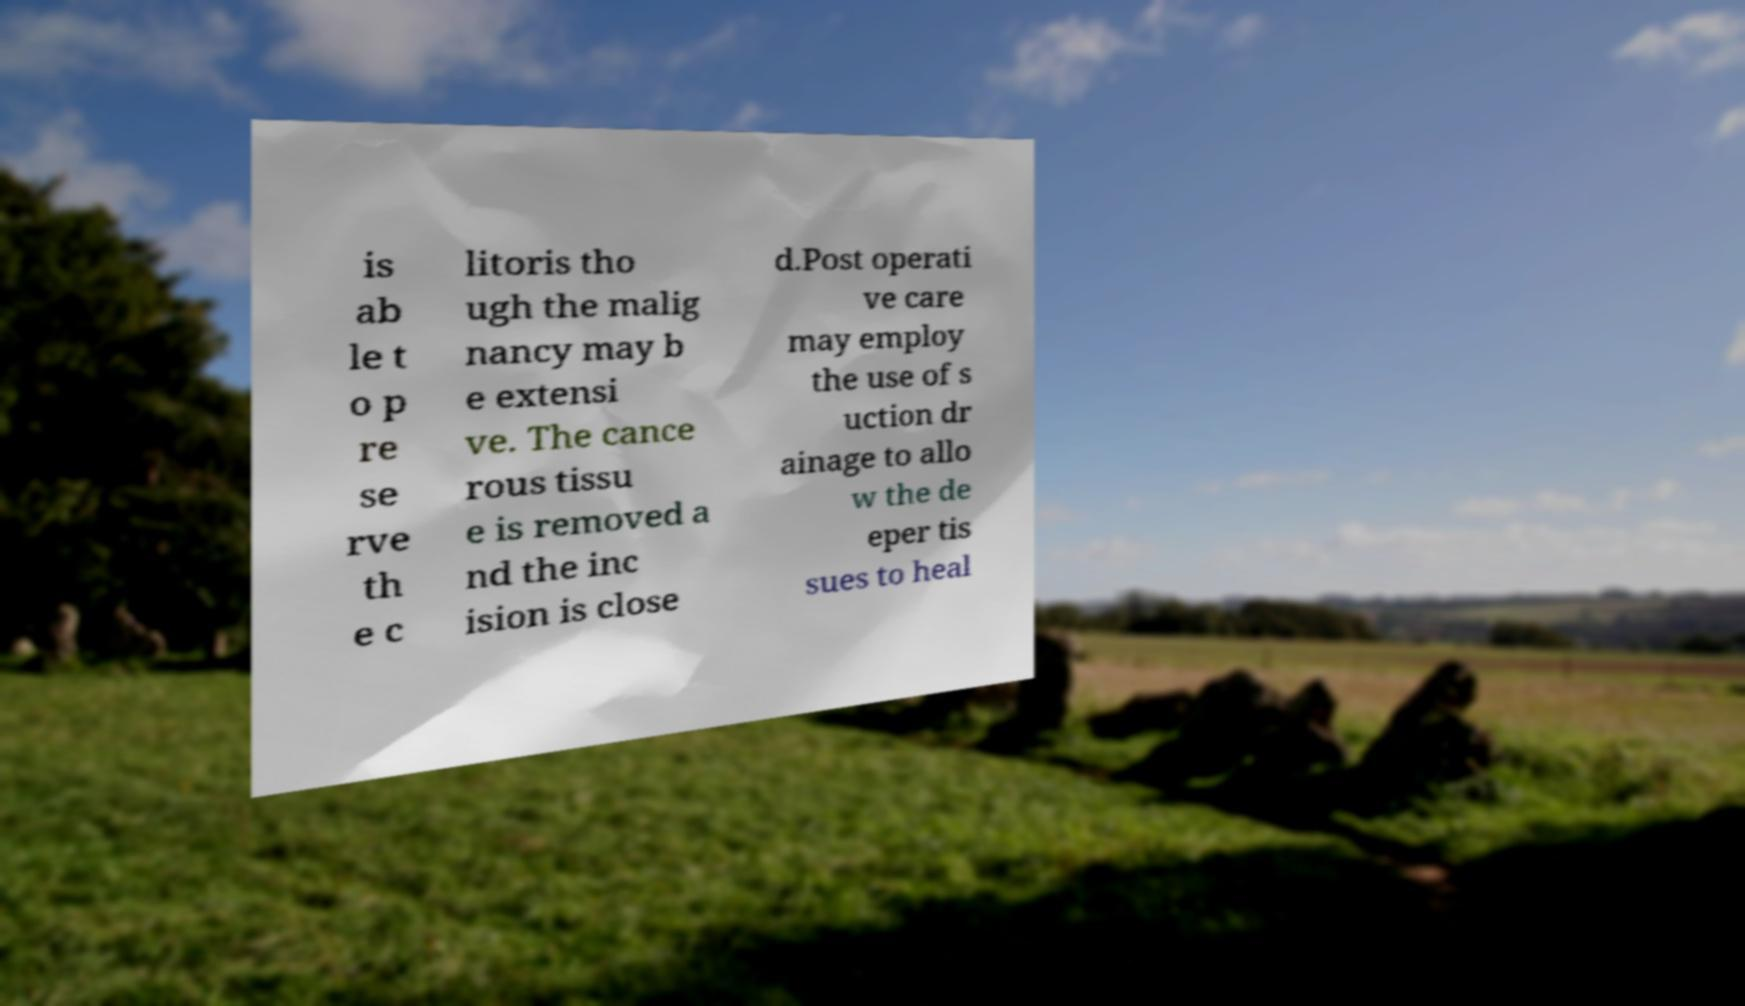For documentation purposes, I need the text within this image transcribed. Could you provide that? is ab le t o p re se rve th e c litoris tho ugh the malig nancy may b e extensi ve. The cance rous tissu e is removed a nd the inc ision is close d.Post operati ve care may employ the use of s uction dr ainage to allo w the de eper tis sues to heal 